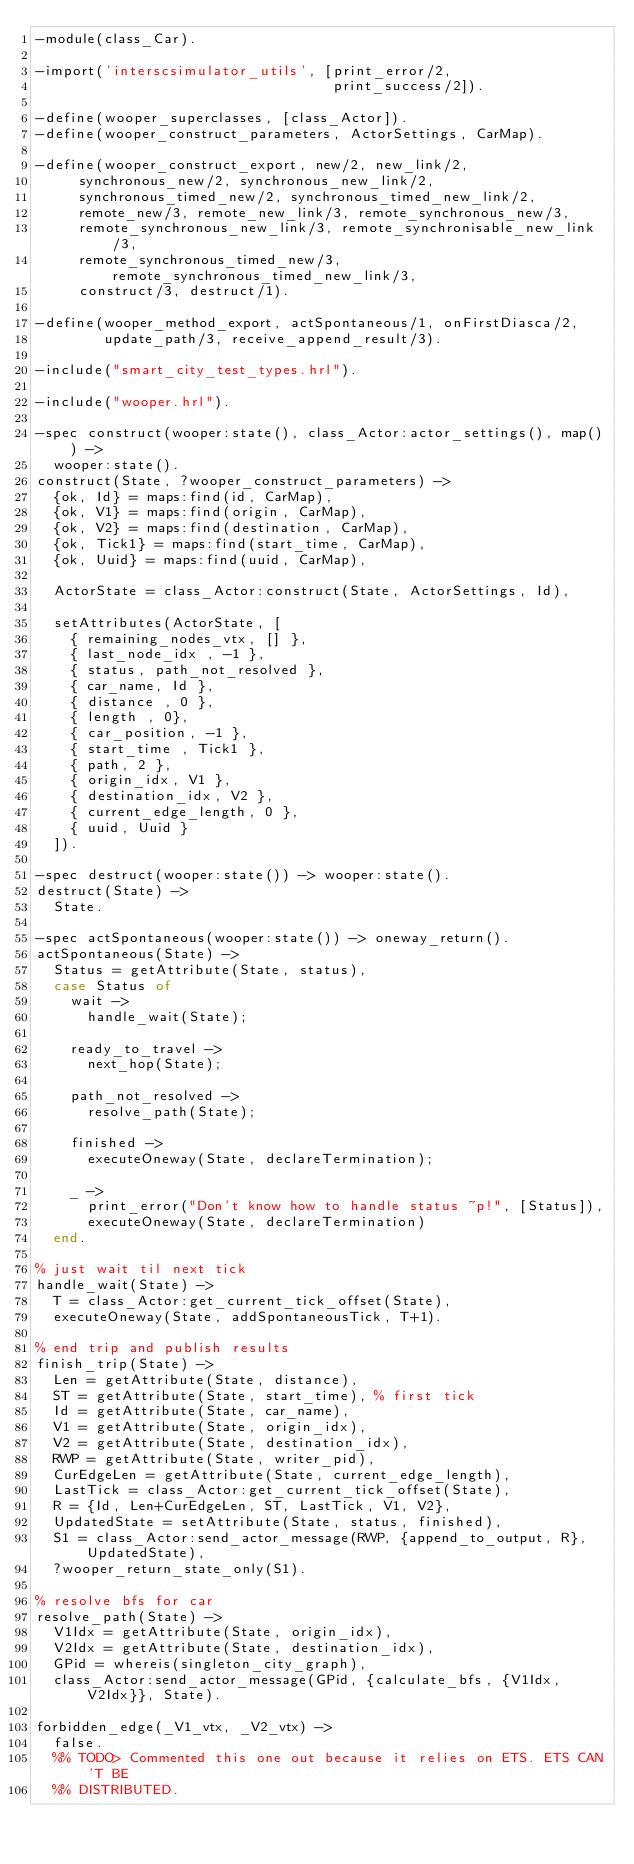<code> <loc_0><loc_0><loc_500><loc_500><_Erlang_>-module(class_Car).

-import('interscsimulator_utils', [print_error/2,
                                   print_success/2]).

-define(wooper_superclasses, [class_Actor]).
-define(wooper_construct_parameters, ActorSettings, CarMap).

-define(wooper_construct_export, new/2, new_link/2,
		 synchronous_new/2, synchronous_new_link/2,
		 synchronous_timed_new/2, synchronous_timed_new_link/2,
		 remote_new/3, remote_new_link/3, remote_synchronous_new/3,
		 remote_synchronous_new_link/3, remote_synchronisable_new_link/3,
		 remote_synchronous_timed_new/3, remote_synchronous_timed_new_link/3,
		 construct/3, destruct/1).

-define(wooper_method_export, actSpontaneous/1, onFirstDiasca/2,
        update_path/3, receive_append_result/3).

-include("smart_city_test_types.hrl").

-include("wooper.hrl").

-spec construct(wooper:state(), class_Actor:actor_settings(), map()) ->
  wooper:state().
construct(State, ?wooper_construct_parameters) ->
  {ok, Id} = maps:find(id, CarMap),
  {ok, V1} = maps:find(origin, CarMap),
  {ok, V2} = maps:find(destination, CarMap),
  {ok, Tick1} = maps:find(start_time, CarMap),
  {ok, Uuid} = maps:find(uuid, CarMap),

	ActorState = class_Actor:construct(State, ActorSettings, Id),

	setAttributes(ActorState, [
    { remaining_nodes_vtx, [] },
    { last_node_idx , -1 },
    { status, path_not_resolved },
		{ car_name, Id },
		{ distance , 0 },
    { length , 0},
		{ car_position, -1 },
		{ start_time , Tick1 },
		{ path, 2 },
    { origin_idx, V1 },
    { destination_idx, V2 },
    { current_edge_length, 0 },
    { uuid, Uuid }
  ]).

-spec destruct(wooper:state()) -> wooper:state().
destruct(State) ->
  State.

-spec actSpontaneous(wooper:state()) -> oneway_return().
actSpontaneous(State) ->
  Status = getAttribute(State, status),
  case Status of
    wait ->
      handle_wait(State);

    ready_to_travel ->
      next_hop(State);

    path_not_resolved ->
      resolve_path(State);

    finished ->
      executeOneway(State, declareTermination);

    _ ->
      print_error("Don't know how to handle status ~p!", [Status]),
      executeOneway(State, declareTermination)
  end.

% just wait til next tick
handle_wait(State) ->
  T = class_Actor:get_current_tick_offset(State),
	executeOneway(State, addSpontaneousTick, T+1).

% end trip and publish results
finish_trip(State) ->
  Len = getAttribute(State, distance),
  ST = getAttribute(State, start_time), % first tick
  Id = getAttribute(State, car_name),
  V1 = getAttribute(State, origin_idx),
  V2 = getAttribute(State, destination_idx),
  RWP = getAttribute(State, writer_pid),
  CurEdgeLen = getAttribute(State, current_edge_length),
  LastTick = class_Actor:get_current_tick_offset(State),
  R = {Id, Len+CurEdgeLen, ST, LastTick, V1, V2},
  UpdatedState = setAttribute(State, status, finished),
  S1 = class_Actor:send_actor_message(RWP, {append_to_output, R}, UpdatedState),
  ?wooper_return_state_only(S1).

% resolve bfs for car
resolve_path(State) ->
  V1Idx = getAttribute(State, origin_idx),
  V2Idx = getAttribute(State, destination_idx),
  GPid = whereis(singleton_city_graph),
  class_Actor:send_actor_message(GPid, {calculate_bfs, {V1Idx, V2Idx}}, State).

forbidden_edge(_V1_vtx, _V2_vtx) ->
  false.
  %% TODO> Commented this one out because it relies on ETS. ETS CAN'T BE
  %% DISTRIBUTED.</code> 